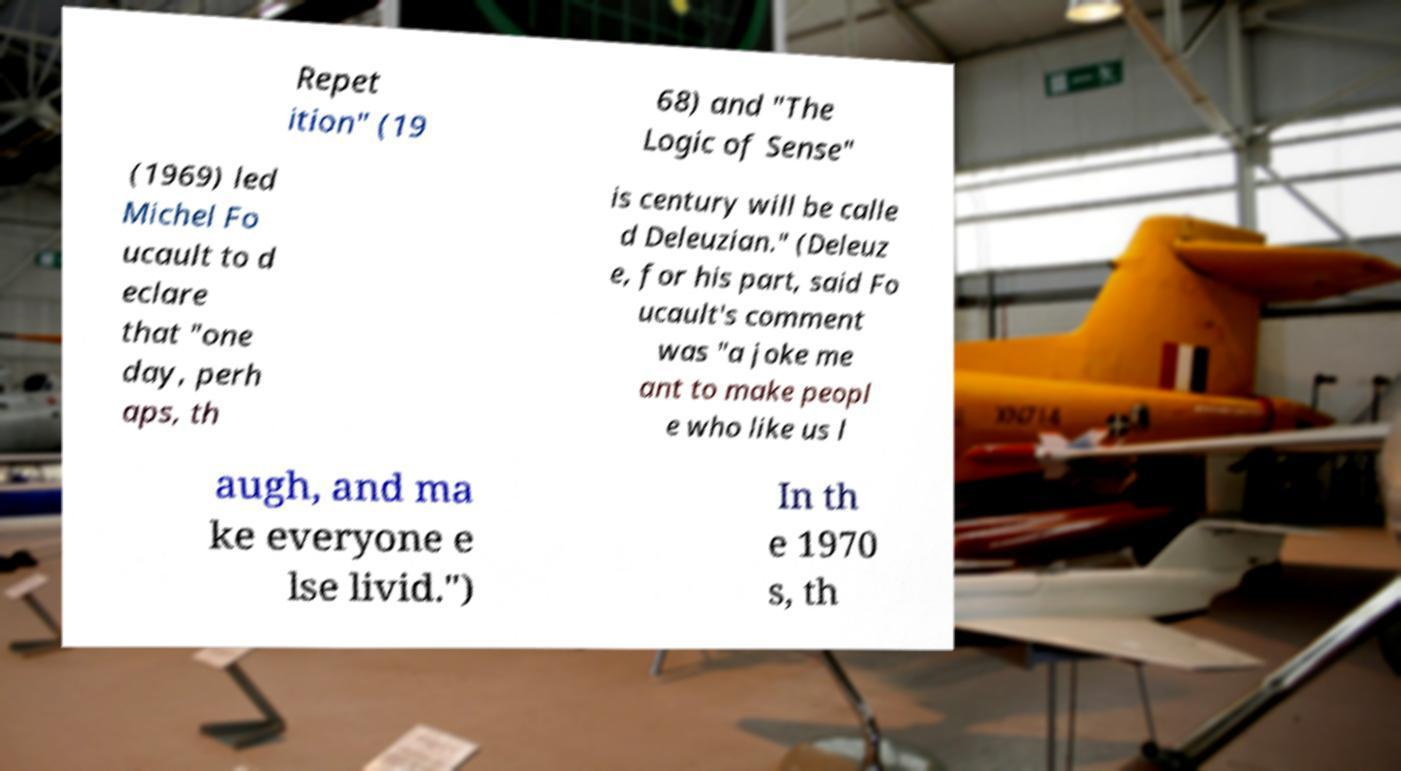Please read and relay the text visible in this image. What does it say? Repet ition" (19 68) and "The Logic of Sense" (1969) led Michel Fo ucault to d eclare that "one day, perh aps, th is century will be calle d Deleuzian." (Deleuz e, for his part, said Fo ucault's comment was "a joke me ant to make peopl e who like us l augh, and ma ke everyone e lse livid.") In th e 1970 s, th 